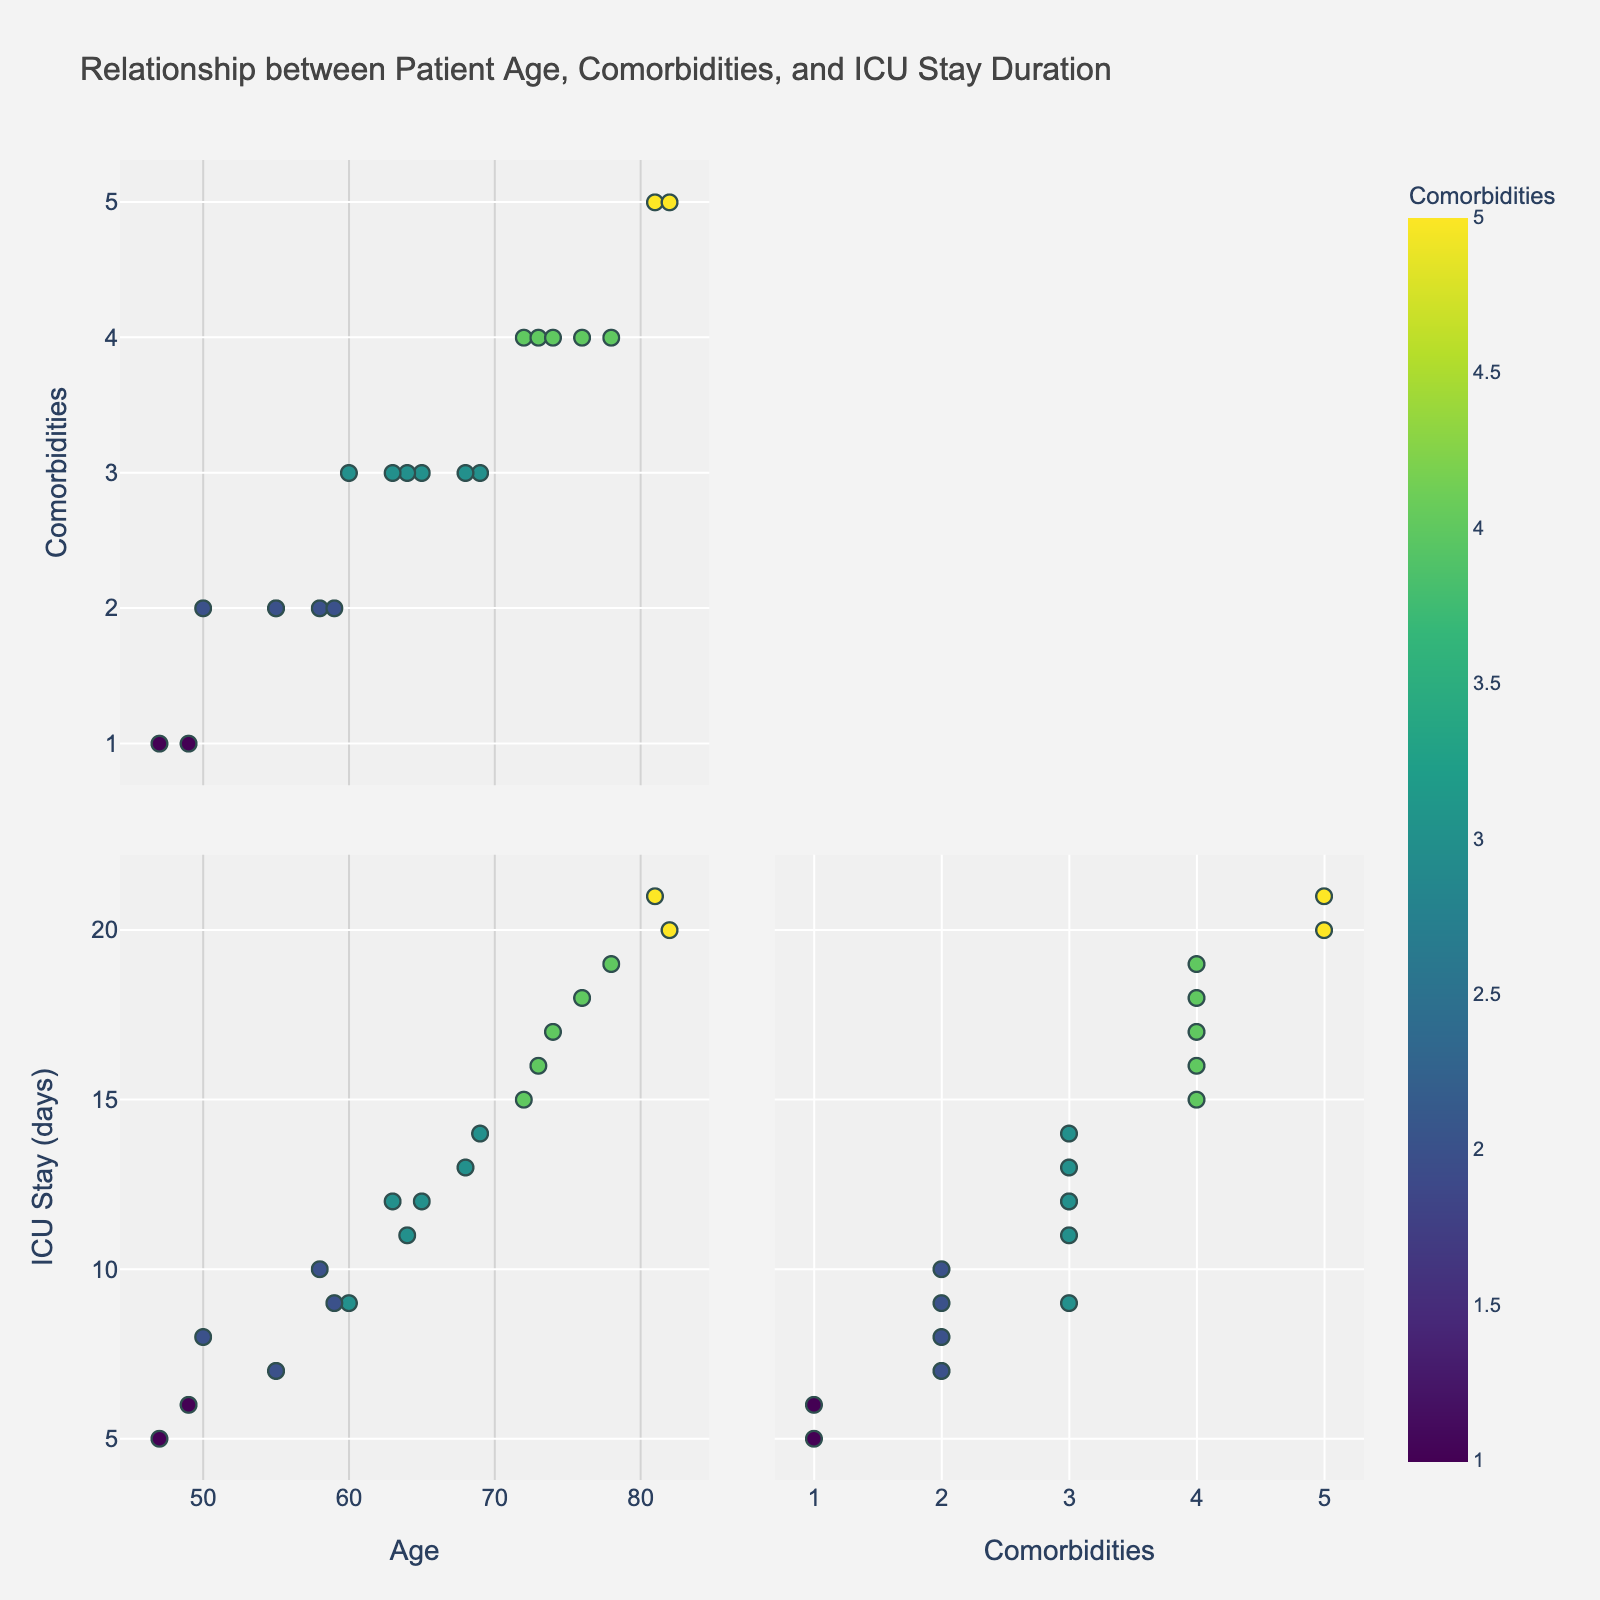How many total data points are represented in the plot? To find the total number of data points, count all the individual plotted points in the scatter plot matrix. Each patient corresponds to one data point.
Answer: 20 What does the color in the plot represent? The color in the scatter plot matrix represents the 'Comorbidity Frequency' of the patients, with different shades or colors indicating different frequencies.
Answer: Comorbidity Frequency Which age group tends to have the longest ICU stay? By observing the scatter plots of 'Patient Age' versus 'Length of ICU Stay,' notice that patients aged 70 and above generally have longer ICU stays compared to younger age groups.
Answer: 70 and above What is the range of Length of ICU Stay values observed among the patients? To determine the range, find the minimum and maximum values of 'Length of ICU Stay' from the scatter plots. The minimum value is 5 and the maximum is 21. The range is 21 - 5.
Answer: 16 Is there a pattern between 'Patient Age' and 'Comorbidity Frequency'? By examining the scatter plot matrix, notice if there's a trend that emerges. Older patients seem to generally have a higher comorbidity frequency.
Answer: Older patients tend to have more comorbidities Are there any outliers in terms of Length of ICU Stay for patients with fewer comorbidities? Observe if there are any points that significantly stand apart from the others in the plot of 'Comorbidity Frequency' versus 'Length of ICU Stay.' Patients with a comorbidity frequency of 1 generally have shorter ICU stays around 5 to 6 days, with no significant outliers.
Answer: No significant outliers Which patient has the highest number of comorbidities and what is their Length of ICU Stay? Identify the point in the plot with the highest 'Comorbidity Frequency' and check its corresponding 'Length of ICU Stay.' The patient with 5 comorbidities has ICU stays of 20 and 21 days.
Answer: Patient ID 5 and 15, Length of ICU Stay is 21 and 20 days respectively What is the average number of comorbidities for patients aged above 70? Identify the patients aged above 70 from the plot, then sum their comorbidity frequencies and divide by the number of such patients. There are 5 patients (Ages 72, 73, 78, 81, 82) with comorbidities 4, 4, 4, 5, 5 respectively. The sum is 22, and the average is 22/5.
Answer: 4.4 Between which two age groups is the largest gap in Length of ICU Stay observed? Compare the scatter plots of 'Patient Age' versus 'Length of ICU Stay' and look for the largest difference between two age groups' lengths of stay.
Answer: Age 47 and 81, with a gap of 16 days on average (5 vs 21) 